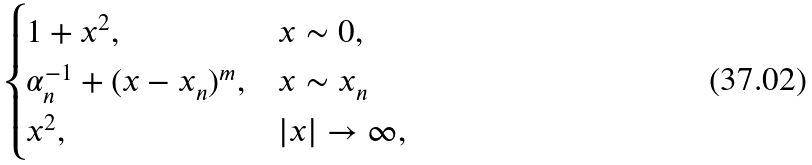<formula> <loc_0><loc_0><loc_500><loc_500>\begin{cases} 1 + x ^ { 2 } , & x \sim 0 , \\ \alpha _ { n } ^ { - 1 } + ( x - x _ { n } ) ^ { m } , & x \sim x _ { n } \\ x ^ { 2 } , & | x | \to \infty , \end{cases}</formula> 